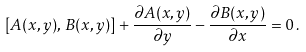Convert formula to latex. <formula><loc_0><loc_0><loc_500><loc_500>[ { A } ( x , y ) , \, { B } ( x , y ) ] + \frac { \partial { A } ( x , y ) } { \partial y } - \frac { \partial { B } ( x , y ) } { \partial x } = 0 \, .</formula> 